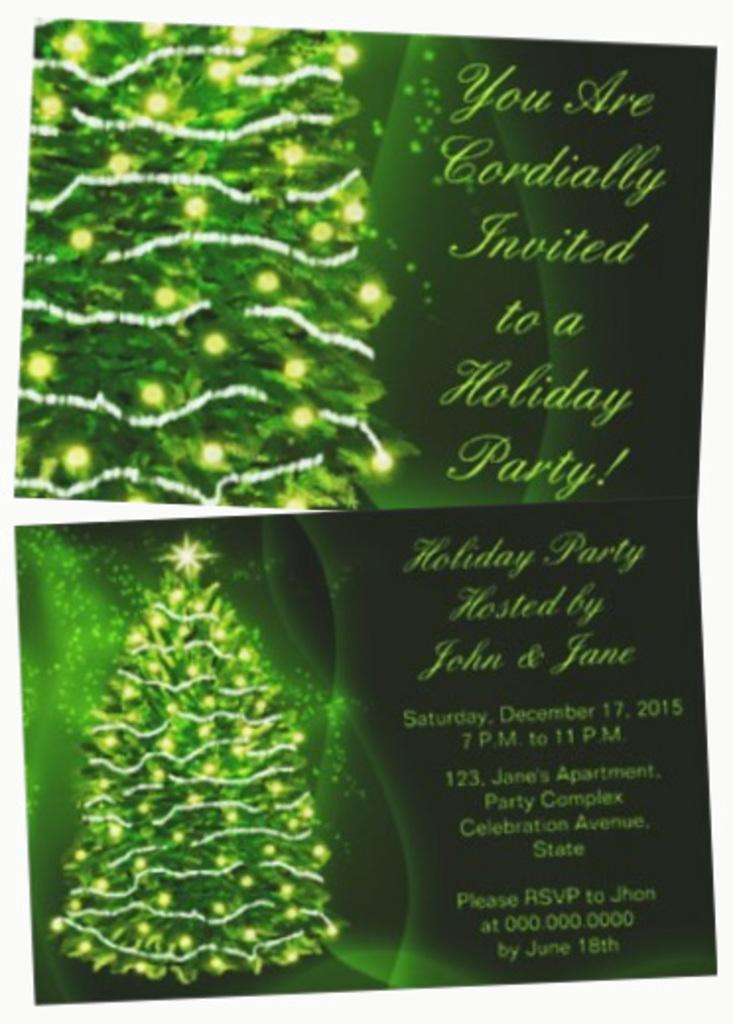What type of tree is in the image? There is an Xmas tree in the image. What feature does the Xmas tree have? The Xmas tree has decorative lights. What else can be seen in the image besides the Xmas tree? There is text in the image. Can you see a key hanging from the Xmas tree in the image? There is no key hanging from the Xmas tree in the image. What type of house is depicted in the image? There is no house depicted in the image; it only features an Xmas tree and text. 